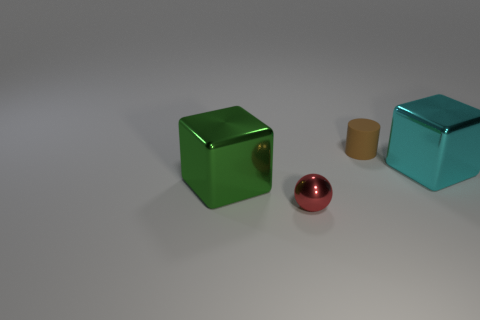Are there fewer tiny red spheres than small purple matte cylinders? Based on the image, there seems to be only one tiny red sphere, and no small purple matte cylinders are visible at all. Therefore, the question may be based on incorrect observations, as there are no purple cylinders to compare with the red sphere. 